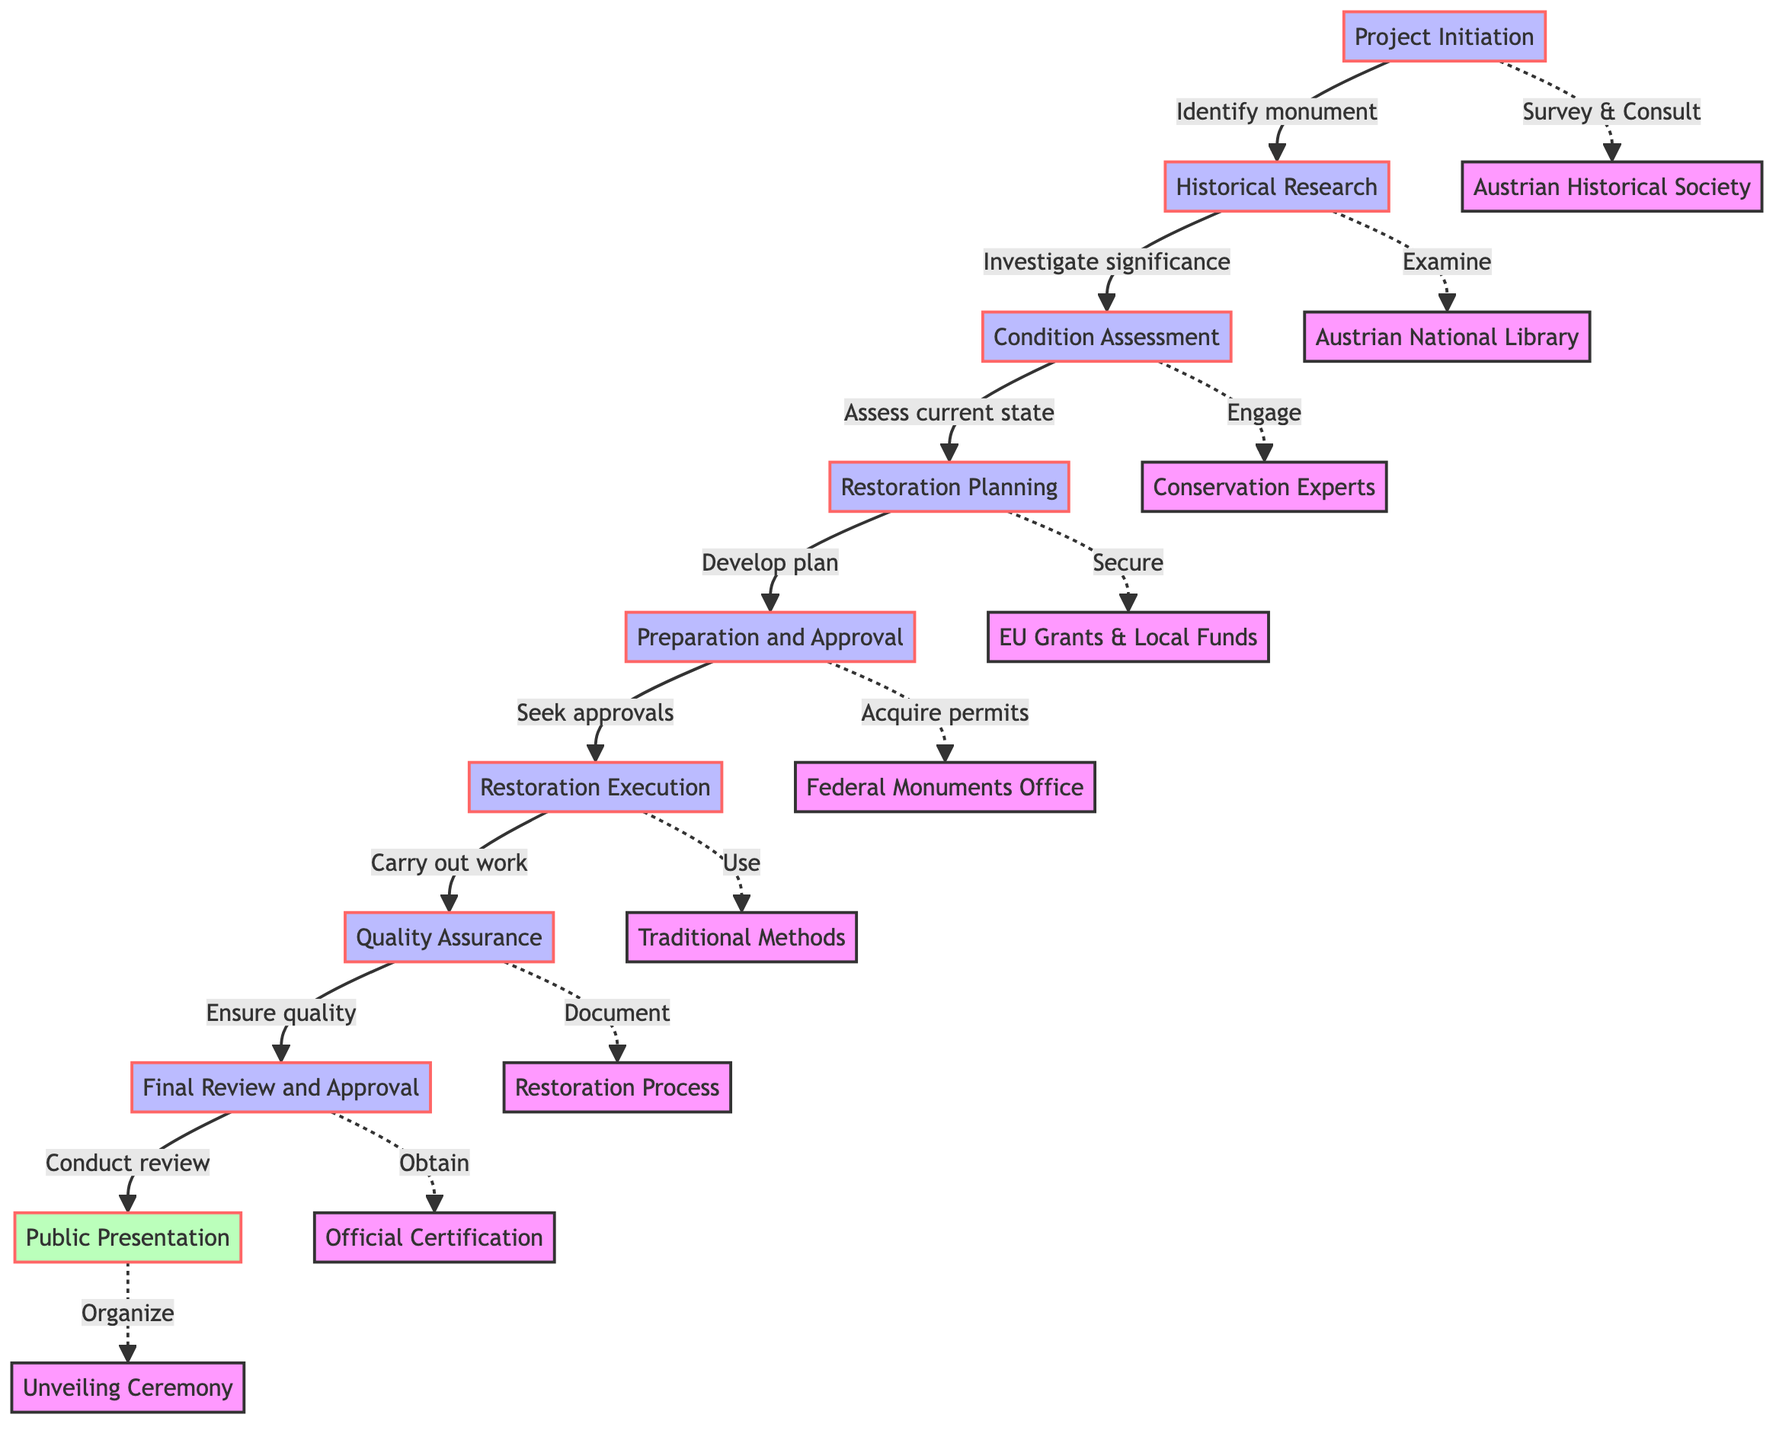What is the first step in the process? The first step in the process is labeled "Project Initiation," which identifies the historical monument requiring restoration. This is the first node in the flowchart.
Answer: Project Initiation How many steps are there in total? By counting the nodes in the diagram, we find that there are nine distinct steps from "Project Initiation" to "Public Presentation."
Answer: Nine What action is taken after "Condition Assessment"? Following "Condition Assessment," the next step is "Restoration Planning," which signifies the transition from assessing the monument's condition to developing a restoration plan.
Answer: Restoration Planning What is necessary before executing the restoration? Before executing the restoration, "Preparation and Approval" must be completed, which includes acquiring permits and approvals. This shows the prerequisite steps needed before restoration can begin.
Answer: Preparation and Approval How does "Restoration Execution" ensure quality? "Restoration Execution" leads into "Quality Assurance," which focuses on ensuring the quality of the restoration by performing inspections, thus it signifies the concept of quality check after the execution phase.
Answer: Quality Assurance What is the final action in the process? The final action in the process is categorized as "Public Presentation," marking the completion of the restoration process and the reintroduction of the monument to the public.
Answer: Public Presentation Which node describes the structural analysis? The node that describes the structural analysis is "Condition Assessment," where the current state of the monument is assessed, including engaging experts for structural assessment.
Answer: Condition Assessment What must be secured during "Restoration Planning"? During "Restoration Planning," costs must be estimated and funding secured through various sources, including EU grants and local government funds. This indicates the financial aspect of planning.
Answer: Secure funding What is the purpose of the "Historical Research" step? The purpose of "Historical Research" is to investigate the historical significance and original state of the monument by examining various historical documents and consulting historians. This sets the foundation for restoring the monument accurately.
Answer: Investigate significance 